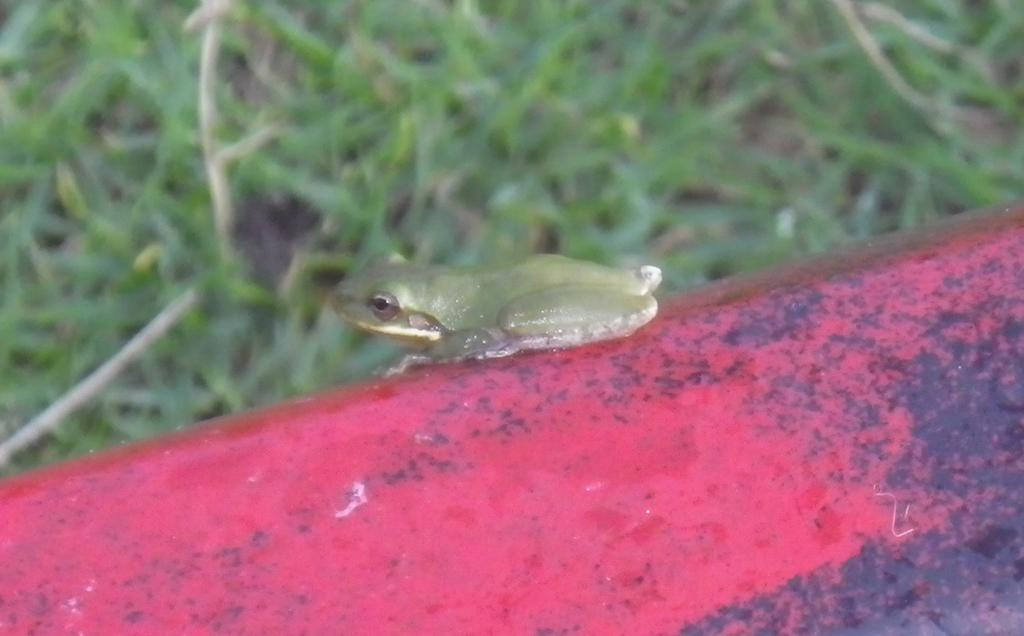What is the main subject in the center of the image? There is a frog in the center of the image. What is the frog resting on? The frog is on a rod. What can be seen in the background of the image? There are plants in the background of the image. What type of dirt can be seen on the frog's throat in the image? There is no dirt or throat visible on the frog in the image; it is simply resting on a rod. 